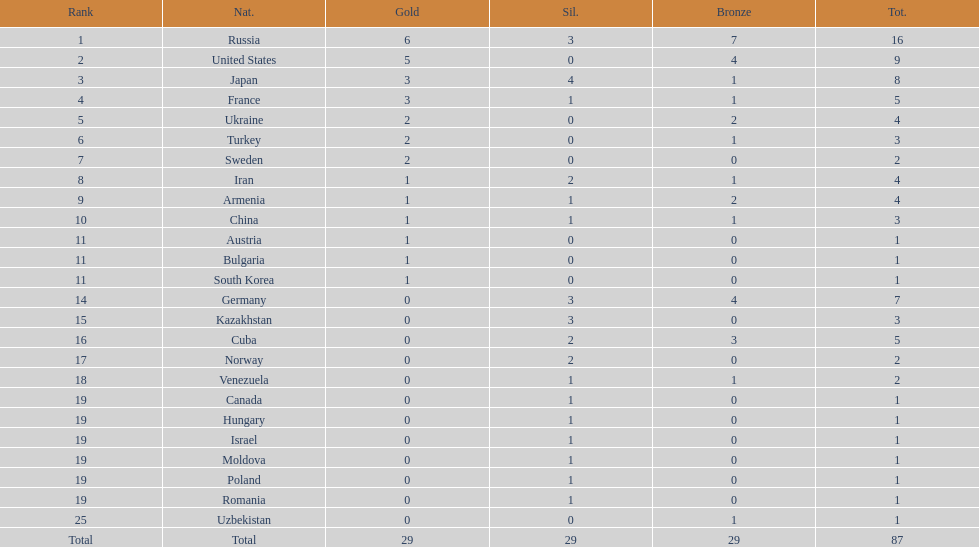Which country had the highest number of medals? Russia. 